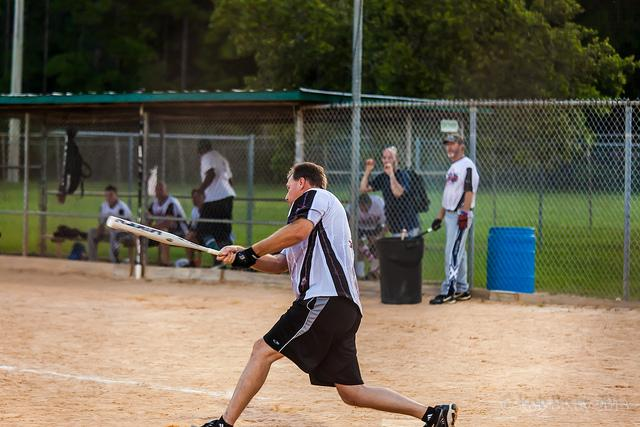What is the most common usage of the black container?

Choices:
A) bats
B) garbage
C) dirt
D) drinks garbage 